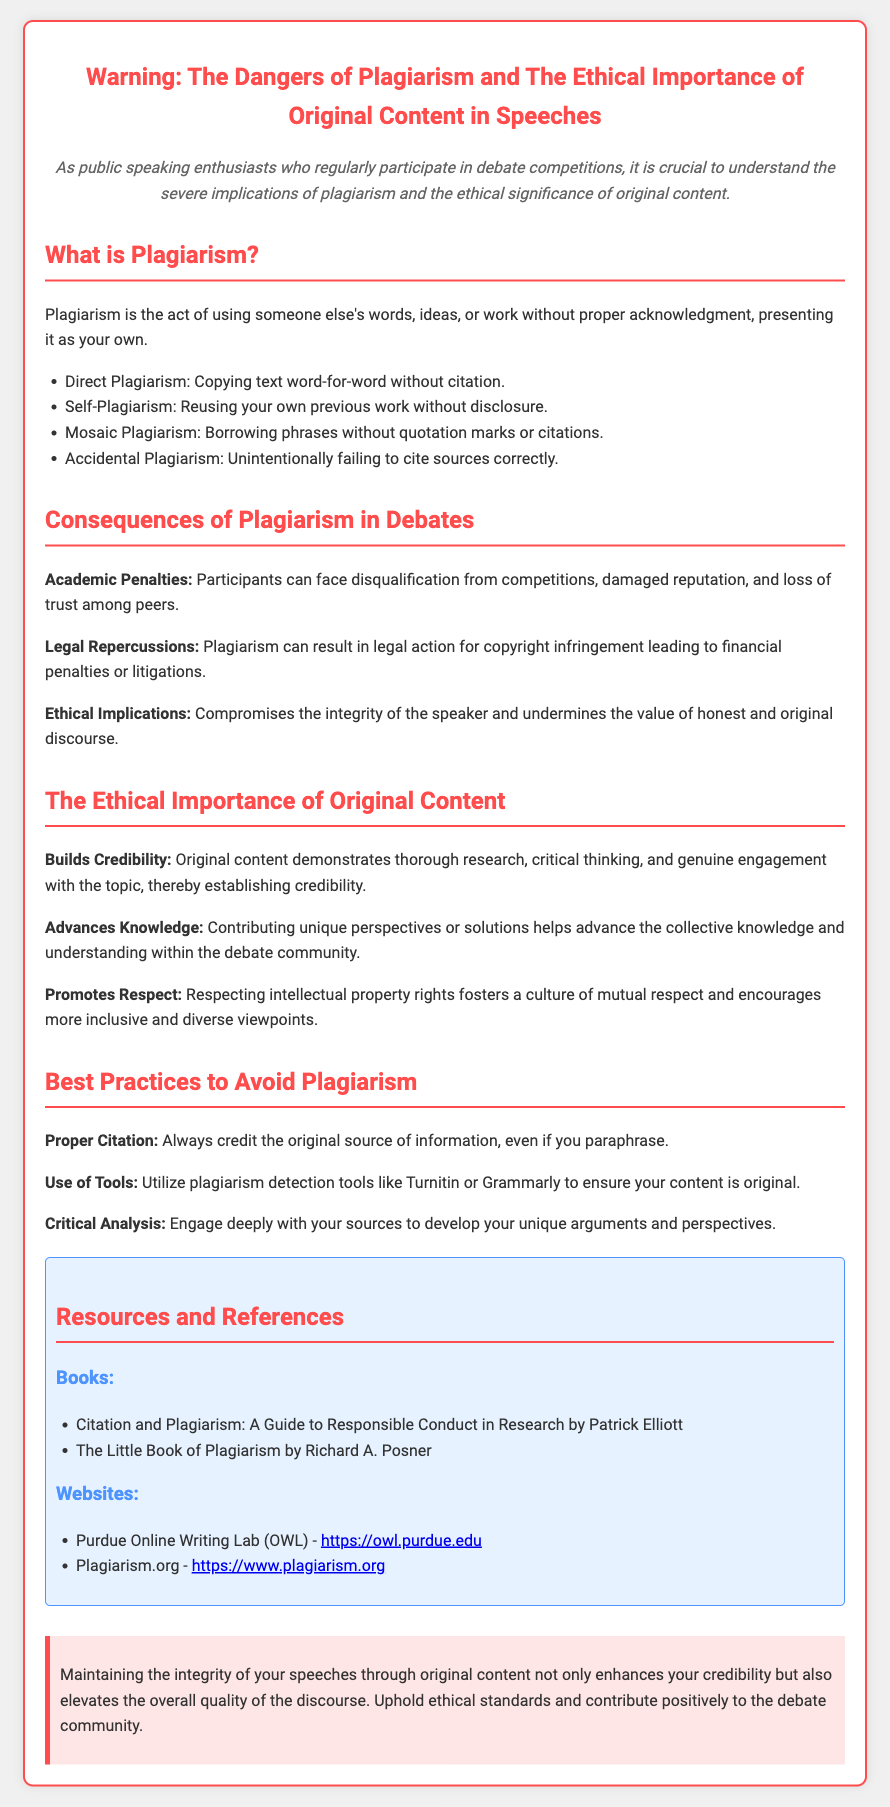What is the title of the document? The title appears at the top of the document as a header.
Answer: Warning: The Dangers of Plagiarism and The Ethical Importance of Original Content in Speeches What are the four types of plagiarism mentioned? The document lists the types of plagiarism in a bulleted format under the section "What is Plagiarism?"
Answer: Direct Plagiarism, Self-Plagiarism, Mosaic Plagiarism, Accidental Plagiarism What are the academic penalties for plagiarism? This information is found in the section regarding the consequences of plagiarism.
Answer: Disqualification from competitions, damaged reputation, and loss of trust among peers Name one tool mentioned that can help to avoid plagiarism. The document suggests using tools in the section "Best Practices to Avoid Plagiarism."
Answer: Turnitin What is one ethical implication of plagiarism? It is explained in the section about the consequences of plagiarism.
Answer: Compromises the integrity of the speaker How does original content affect credibility? The document explains this in the section on the ethical importance of original content.
Answer: It demonstrates thorough research, critical thinking, and genuine engagement What is the focus of the resources section? The section lists books and websites that provide further guidance on citation and plagiarism.
Answer: Books and Websites What should participants in debates prioritize according to the conclusion? The conclusion emphasizes maintaining a specific value or practice related to speech content.
Answer: Integrity of your speeches through original content 